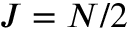<formula> <loc_0><loc_0><loc_500><loc_500>J = N / 2</formula> 